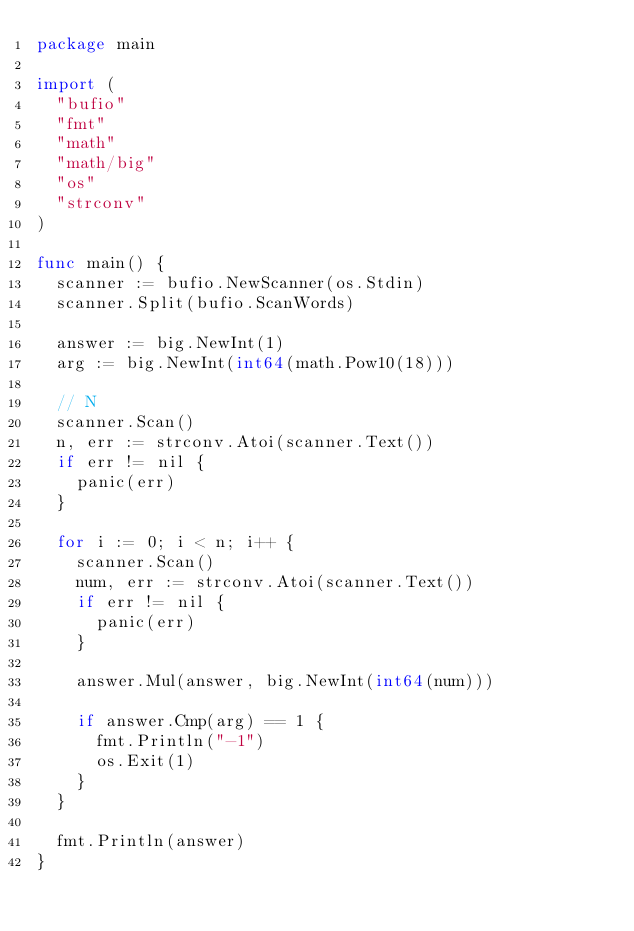<code> <loc_0><loc_0><loc_500><loc_500><_Go_>package main

import (
	"bufio"
	"fmt"
	"math"
	"math/big"
	"os"
	"strconv"
)

func main() {
	scanner := bufio.NewScanner(os.Stdin)
	scanner.Split(bufio.ScanWords)

	answer := big.NewInt(1)
	arg := big.NewInt(int64(math.Pow10(18)))

	// N
	scanner.Scan()
	n, err := strconv.Atoi(scanner.Text())
	if err != nil {
		panic(err)
	}

	for i := 0; i < n; i++ {
		scanner.Scan()
		num, err := strconv.Atoi(scanner.Text())
		if err != nil {
			panic(err)
		}

		answer.Mul(answer, big.NewInt(int64(num)))

		if answer.Cmp(arg) == 1 {
			fmt.Println("-1")
			os.Exit(1)
		}
	}

	fmt.Println(answer)
}
</code> 